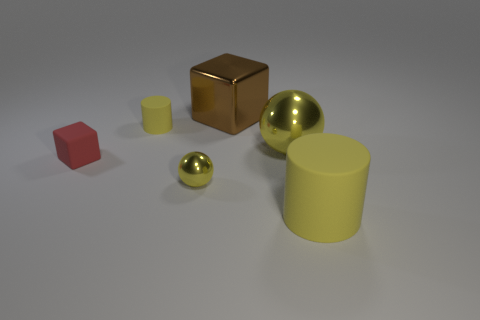Can you describe the colors and materials visible in the scene? Certainly! In the image, there is a variety of objects with different colors and possible materials. There is a red cube, a small yellow cylinder, a larger yellow cylinder, a metal-looking cube, and two spheres that seem metallic as well—one larger and one smaller. The colors include primary red and yellow, and the metallic objects suggest a shiny and reflective surface, likely representing materials such as steel or aluminum. 